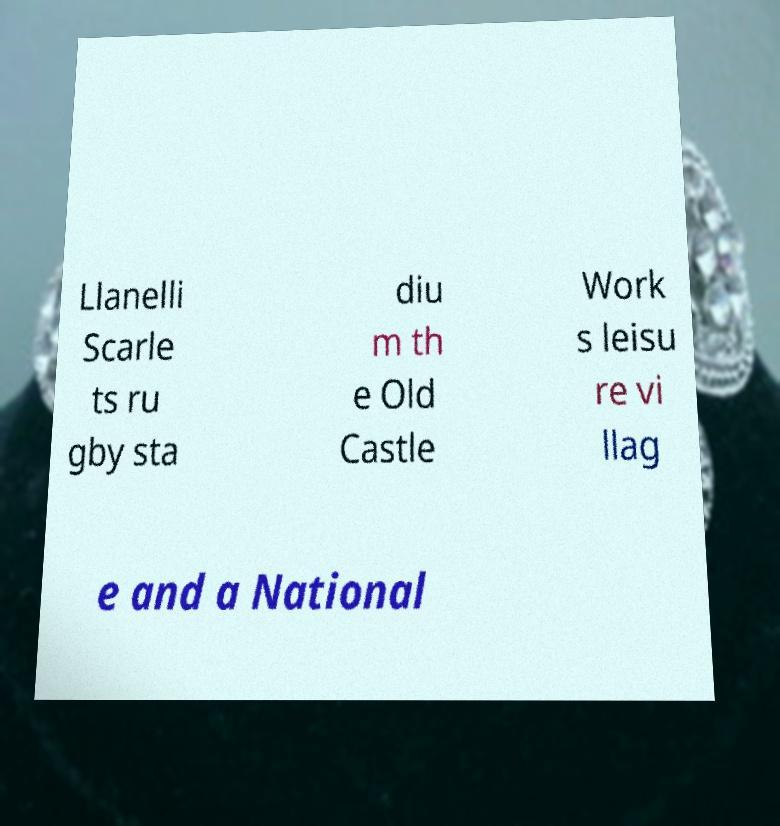What messages or text are displayed in this image? I need them in a readable, typed format. Llanelli Scarle ts ru gby sta diu m th e Old Castle Work s leisu re vi llag e and a National 